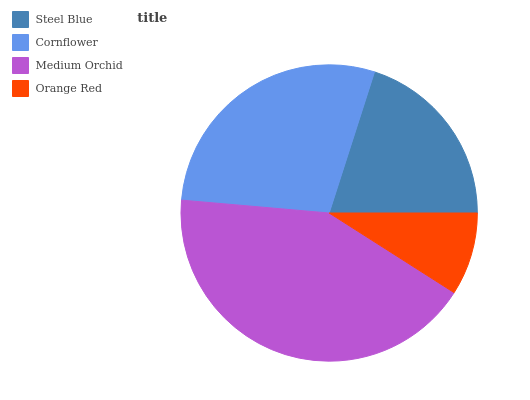Is Orange Red the minimum?
Answer yes or no. Yes. Is Medium Orchid the maximum?
Answer yes or no. Yes. Is Cornflower the minimum?
Answer yes or no. No. Is Cornflower the maximum?
Answer yes or no. No. Is Cornflower greater than Steel Blue?
Answer yes or no. Yes. Is Steel Blue less than Cornflower?
Answer yes or no. Yes. Is Steel Blue greater than Cornflower?
Answer yes or no. No. Is Cornflower less than Steel Blue?
Answer yes or no. No. Is Cornflower the high median?
Answer yes or no. Yes. Is Steel Blue the low median?
Answer yes or no. Yes. Is Steel Blue the high median?
Answer yes or no. No. Is Cornflower the low median?
Answer yes or no. No. 